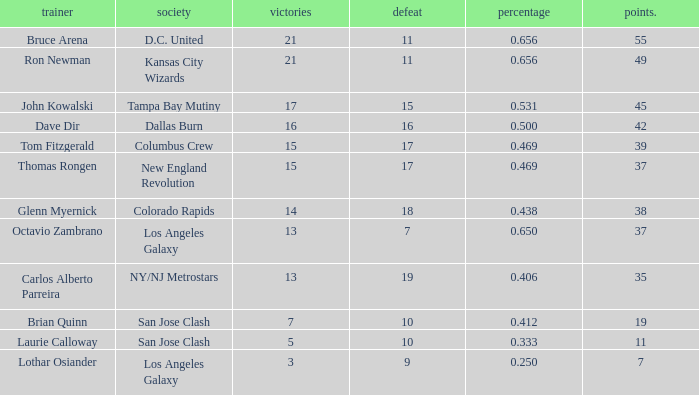What is the maximum percentage of bruce arena when he suffers over 11 losses? None. 